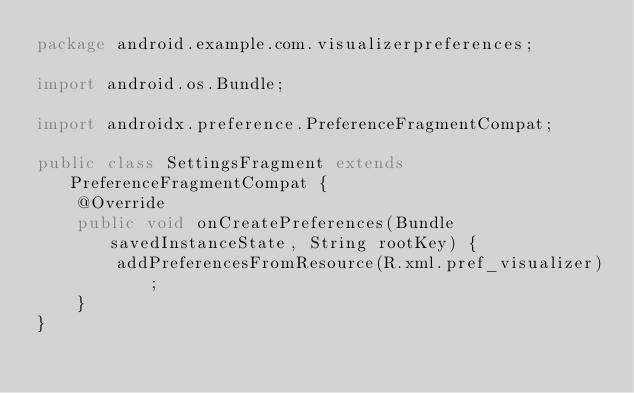Convert code to text. <code><loc_0><loc_0><loc_500><loc_500><_Java_>package android.example.com.visualizerpreferences;

import android.os.Bundle;

import androidx.preference.PreferenceFragmentCompat;

public class SettingsFragment extends PreferenceFragmentCompat {
    @Override
    public void onCreatePreferences(Bundle savedInstanceState, String rootKey) {
        addPreferencesFromResource(R.xml.pref_visualizer);
    }
}
</code> 